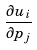Convert formula to latex. <formula><loc_0><loc_0><loc_500><loc_500>\frac { \partial u _ { i } } { \partial p _ { j } }</formula> 